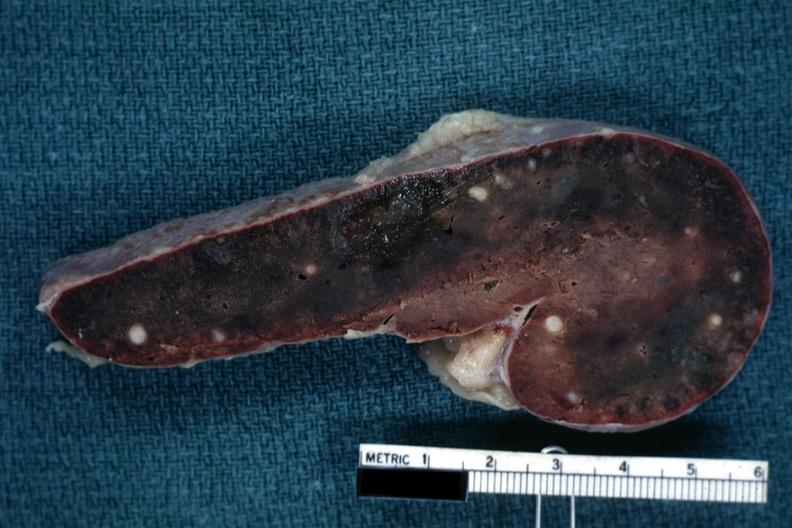s aorta present?
Answer the question using a single word or phrase. No 